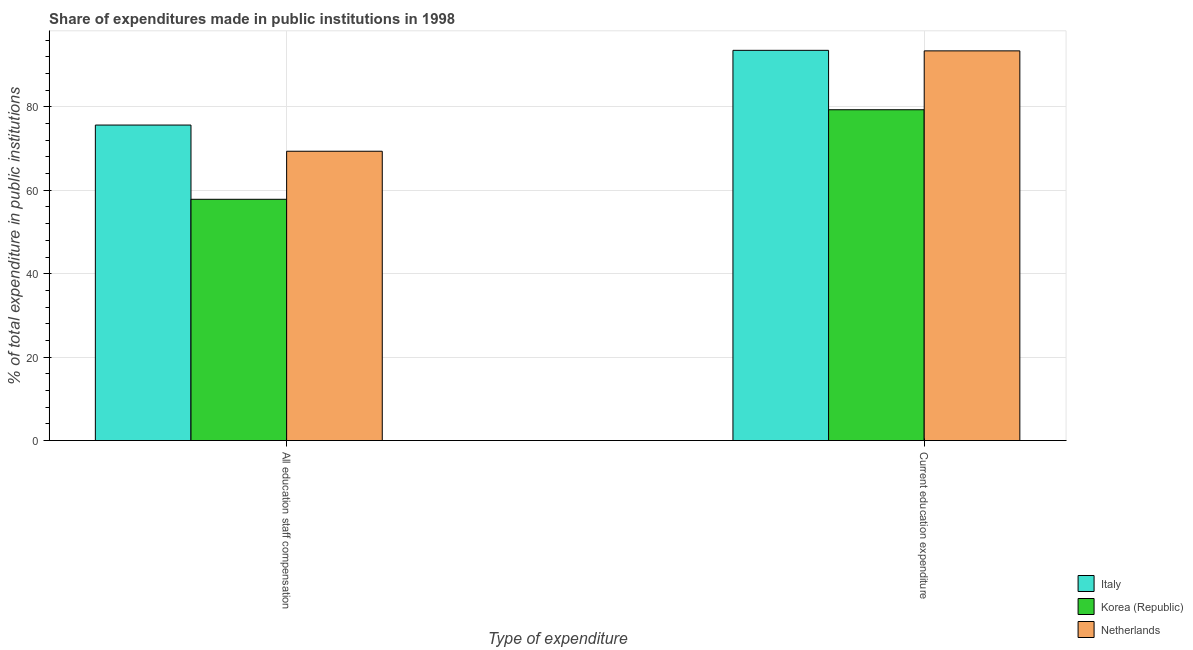How many different coloured bars are there?
Ensure brevity in your answer.  3. How many groups of bars are there?
Provide a short and direct response. 2. Are the number of bars on each tick of the X-axis equal?
Give a very brief answer. Yes. How many bars are there on the 2nd tick from the left?
Keep it short and to the point. 3. How many bars are there on the 2nd tick from the right?
Ensure brevity in your answer.  3. What is the label of the 1st group of bars from the left?
Give a very brief answer. All education staff compensation. What is the expenditure in staff compensation in Korea (Republic)?
Provide a short and direct response. 57.83. Across all countries, what is the maximum expenditure in staff compensation?
Offer a terse response. 75.63. Across all countries, what is the minimum expenditure in education?
Offer a terse response. 79.3. What is the total expenditure in staff compensation in the graph?
Your answer should be very brief. 202.81. What is the difference between the expenditure in staff compensation in Netherlands and that in Italy?
Your response must be concise. -6.28. What is the difference between the expenditure in education in Korea (Republic) and the expenditure in staff compensation in Italy?
Your response must be concise. 3.67. What is the average expenditure in education per country?
Provide a short and direct response. 88.75. What is the difference between the expenditure in staff compensation and expenditure in education in Italy?
Offer a terse response. -17.91. In how many countries, is the expenditure in staff compensation greater than 28 %?
Ensure brevity in your answer.  3. What is the ratio of the expenditure in staff compensation in Netherlands to that in Korea (Republic)?
Your answer should be very brief. 1.2. In how many countries, is the expenditure in staff compensation greater than the average expenditure in staff compensation taken over all countries?
Your answer should be very brief. 2. What does the 2nd bar from the left in All education staff compensation represents?
Provide a short and direct response. Korea (Republic). Are all the bars in the graph horizontal?
Give a very brief answer. No. What is the difference between two consecutive major ticks on the Y-axis?
Your answer should be compact. 20. Are the values on the major ticks of Y-axis written in scientific E-notation?
Your answer should be compact. No. Does the graph contain any zero values?
Provide a short and direct response. No. How many legend labels are there?
Offer a very short reply. 3. What is the title of the graph?
Keep it short and to the point. Share of expenditures made in public institutions in 1998. Does "Turks and Caicos Islands" appear as one of the legend labels in the graph?
Your answer should be compact. No. What is the label or title of the X-axis?
Give a very brief answer. Type of expenditure. What is the label or title of the Y-axis?
Your response must be concise. % of total expenditure in public institutions. What is the % of total expenditure in public institutions of Italy in All education staff compensation?
Provide a succinct answer. 75.63. What is the % of total expenditure in public institutions of Korea (Republic) in All education staff compensation?
Your response must be concise. 57.83. What is the % of total expenditure in public institutions of Netherlands in All education staff compensation?
Make the answer very short. 69.35. What is the % of total expenditure in public institutions in Italy in Current education expenditure?
Provide a short and direct response. 93.54. What is the % of total expenditure in public institutions in Korea (Republic) in Current education expenditure?
Your response must be concise. 79.3. What is the % of total expenditure in public institutions of Netherlands in Current education expenditure?
Your answer should be very brief. 93.41. Across all Type of expenditure, what is the maximum % of total expenditure in public institutions in Italy?
Make the answer very short. 93.54. Across all Type of expenditure, what is the maximum % of total expenditure in public institutions of Korea (Republic)?
Offer a terse response. 79.3. Across all Type of expenditure, what is the maximum % of total expenditure in public institutions in Netherlands?
Your answer should be compact. 93.41. Across all Type of expenditure, what is the minimum % of total expenditure in public institutions in Italy?
Your response must be concise. 75.63. Across all Type of expenditure, what is the minimum % of total expenditure in public institutions in Korea (Republic)?
Make the answer very short. 57.83. Across all Type of expenditure, what is the minimum % of total expenditure in public institutions in Netherlands?
Provide a succinct answer. 69.35. What is the total % of total expenditure in public institutions in Italy in the graph?
Ensure brevity in your answer.  169.16. What is the total % of total expenditure in public institutions in Korea (Republic) in the graph?
Your answer should be very brief. 137.13. What is the total % of total expenditure in public institutions of Netherlands in the graph?
Ensure brevity in your answer.  162.76. What is the difference between the % of total expenditure in public institutions in Italy in All education staff compensation and that in Current education expenditure?
Make the answer very short. -17.91. What is the difference between the % of total expenditure in public institutions in Korea (Republic) in All education staff compensation and that in Current education expenditure?
Offer a very short reply. -21.47. What is the difference between the % of total expenditure in public institutions in Netherlands in All education staff compensation and that in Current education expenditure?
Offer a terse response. -24.06. What is the difference between the % of total expenditure in public institutions in Italy in All education staff compensation and the % of total expenditure in public institutions in Korea (Republic) in Current education expenditure?
Offer a terse response. -3.67. What is the difference between the % of total expenditure in public institutions of Italy in All education staff compensation and the % of total expenditure in public institutions of Netherlands in Current education expenditure?
Your answer should be very brief. -17.78. What is the difference between the % of total expenditure in public institutions of Korea (Republic) in All education staff compensation and the % of total expenditure in public institutions of Netherlands in Current education expenditure?
Offer a very short reply. -35.58. What is the average % of total expenditure in public institutions in Italy per Type of expenditure?
Your response must be concise. 84.58. What is the average % of total expenditure in public institutions in Korea (Republic) per Type of expenditure?
Your answer should be very brief. 68.56. What is the average % of total expenditure in public institutions of Netherlands per Type of expenditure?
Your answer should be compact. 81.38. What is the difference between the % of total expenditure in public institutions of Italy and % of total expenditure in public institutions of Korea (Republic) in All education staff compensation?
Offer a terse response. 17.79. What is the difference between the % of total expenditure in public institutions of Italy and % of total expenditure in public institutions of Netherlands in All education staff compensation?
Provide a short and direct response. 6.28. What is the difference between the % of total expenditure in public institutions in Korea (Republic) and % of total expenditure in public institutions in Netherlands in All education staff compensation?
Your answer should be very brief. -11.52. What is the difference between the % of total expenditure in public institutions of Italy and % of total expenditure in public institutions of Korea (Republic) in Current education expenditure?
Offer a very short reply. 14.24. What is the difference between the % of total expenditure in public institutions in Italy and % of total expenditure in public institutions in Netherlands in Current education expenditure?
Provide a succinct answer. 0.13. What is the difference between the % of total expenditure in public institutions of Korea (Republic) and % of total expenditure in public institutions of Netherlands in Current education expenditure?
Your answer should be very brief. -14.11. What is the ratio of the % of total expenditure in public institutions in Italy in All education staff compensation to that in Current education expenditure?
Offer a terse response. 0.81. What is the ratio of the % of total expenditure in public institutions in Korea (Republic) in All education staff compensation to that in Current education expenditure?
Keep it short and to the point. 0.73. What is the ratio of the % of total expenditure in public institutions in Netherlands in All education staff compensation to that in Current education expenditure?
Keep it short and to the point. 0.74. What is the difference between the highest and the second highest % of total expenditure in public institutions of Italy?
Provide a succinct answer. 17.91. What is the difference between the highest and the second highest % of total expenditure in public institutions of Korea (Republic)?
Your answer should be very brief. 21.47. What is the difference between the highest and the second highest % of total expenditure in public institutions in Netherlands?
Offer a very short reply. 24.06. What is the difference between the highest and the lowest % of total expenditure in public institutions of Italy?
Give a very brief answer. 17.91. What is the difference between the highest and the lowest % of total expenditure in public institutions of Korea (Republic)?
Make the answer very short. 21.47. What is the difference between the highest and the lowest % of total expenditure in public institutions of Netherlands?
Provide a short and direct response. 24.06. 